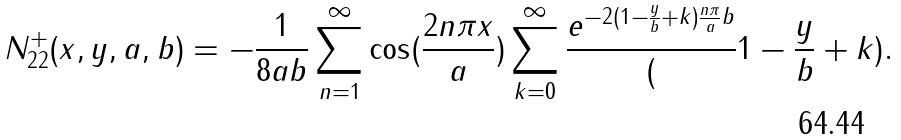Convert formula to latex. <formula><loc_0><loc_0><loc_500><loc_500>N _ { 2 2 } ^ { + } ( x , y , a , b ) = - \frac { 1 } { 8 a b } \sum _ { n = 1 } ^ { \infty } \cos ( \frac { 2 n \pi x } { a } ) \sum _ { k = 0 } ^ { \infty } \frac { e ^ { - 2 ( 1 - \frac { y } { b } + k ) \frac { n \pi } { a } b } } ( 1 - \frac { y } { b } + k ) .</formula> 